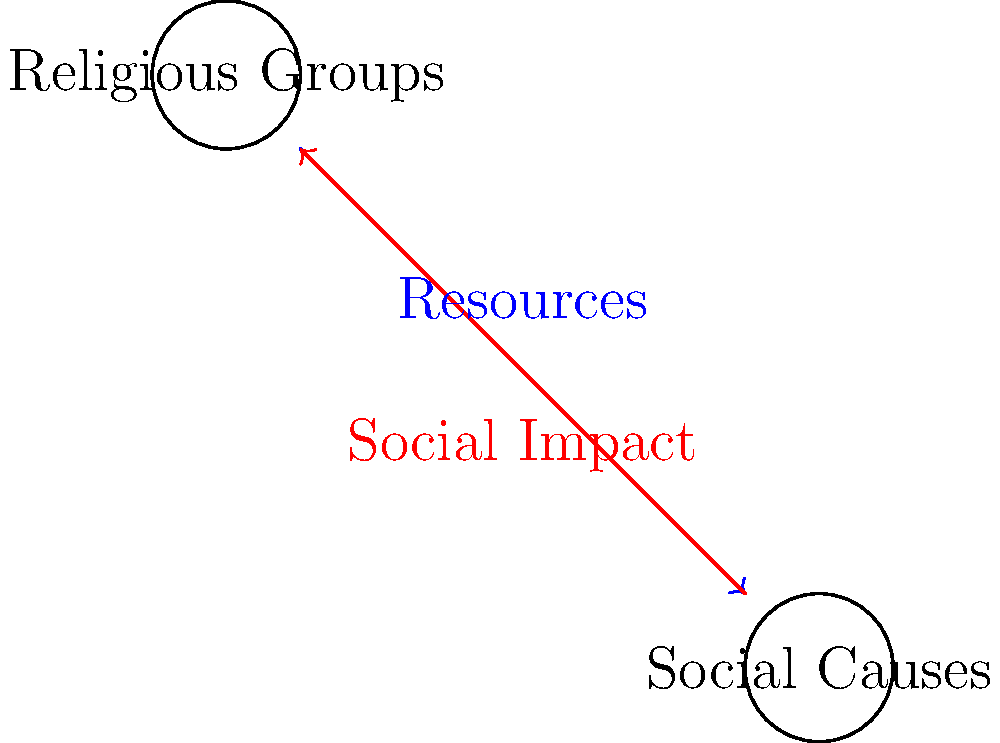In the diagram above, which represents the flow of resources and support between religious groups and social causes, what does the blue arrow signify? To answer this question, let's analyze the diagram step-by-step:

1. The diagram shows two main entities: "Religious Groups" on the top left and "Social Causes" on the bottom right.

2. There are two arrows connecting these entities:
   a. A blue arrow pointing from Religious Groups to Social Causes
   b. A red arrow pointing from Social Causes to Religious Groups

3. The blue arrow is labeled "Resources," indicating that it represents the flow of resources from religious groups to social causes.

4. The red arrow is labeled "Social Impact," suggesting that it represents the impact or influence that social causes have on religious groups.

5. In the context of religion promoting social change, religious groups often provide various forms of support to social causes. These can include:
   - Financial donations
   - Volunteer manpower
   - Organizational support
   - Moral and spiritual guidance

6. The blue arrow, therefore, represents this flow of tangible and intangible resources from religious institutions to various social initiatives and movements.

Given this analysis, the blue arrow signifies the resources that religious groups contribute to social causes, enabling them to pursue their objectives and create social change.
Answer: Resources provided by religious groups to social causes 